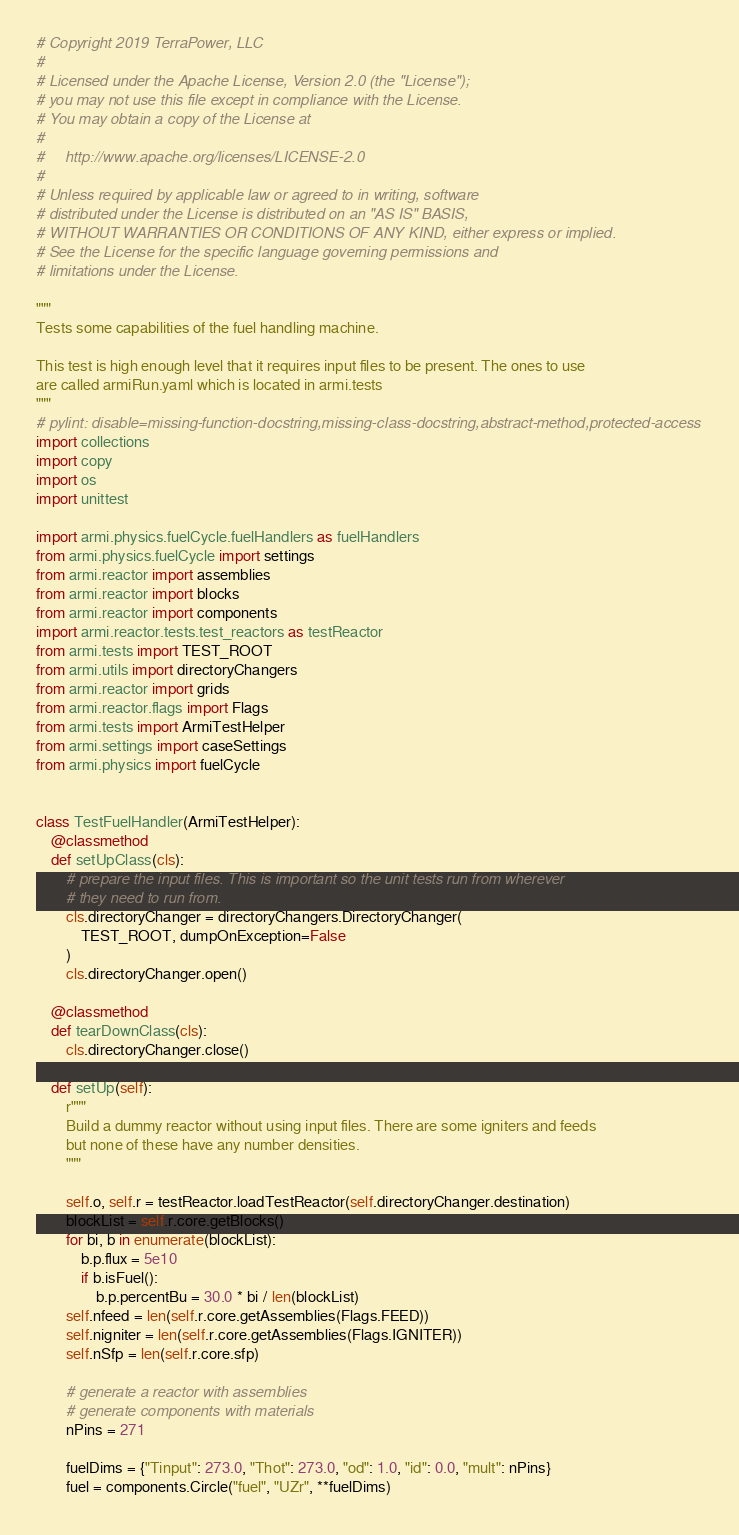Convert code to text. <code><loc_0><loc_0><loc_500><loc_500><_Python_># Copyright 2019 TerraPower, LLC
#
# Licensed under the Apache License, Version 2.0 (the "License");
# you may not use this file except in compliance with the License.
# You may obtain a copy of the License at
#
#     http://www.apache.org/licenses/LICENSE-2.0
#
# Unless required by applicable law or agreed to in writing, software
# distributed under the License is distributed on an "AS IS" BASIS,
# WITHOUT WARRANTIES OR CONDITIONS OF ANY KIND, either express or implied.
# See the License for the specific language governing permissions and
# limitations under the License.

"""
Tests some capabilities of the fuel handling machine.

This test is high enough level that it requires input files to be present. The ones to use
are called armiRun.yaml which is located in armi.tests
"""
# pylint: disable=missing-function-docstring,missing-class-docstring,abstract-method,protected-access
import collections
import copy
import os
import unittest

import armi.physics.fuelCycle.fuelHandlers as fuelHandlers
from armi.physics.fuelCycle import settings
from armi.reactor import assemblies
from armi.reactor import blocks
from armi.reactor import components
import armi.reactor.tests.test_reactors as testReactor
from armi.tests import TEST_ROOT
from armi.utils import directoryChangers
from armi.reactor import grids
from armi.reactor.flags import Flags
from armi.tests import ArmiTestHelper
from armi.settings import caseSettings
from armi.physics import fuelCycle


class TestFuelHandler(ArmiTestHelper):
    @classmethod
    def setUpClass(cls):
        # prepare the input files. This is important so the unit tests run from wherever
        # they need to run from.
        cls.directoryChanger = directoryChangers.DirectoryChanger(
            TEST_ROOT, dumpOnException=False
        )
        cls.directoryChanger.open()

    @classmethod
    def tearDownClass(cls):
        cls.directoryChanger.close()

    def setUp(self):
        r"""
        Build a dummy reactor without using input files. There are some igniters and feeds
        but none of these have any number densities.
        """

        self.o, self.r = testReactor.loadTestReactor(self.directoryChanger.destination)
        blockList = self.r.core.getBlocks()
        for bi, b in enumerate(blockList):
            b.p.flux = 5e10
            if b.isFuel():
                b.p.percentBu = 30.0 * bi / len(blockList)
        self.nfeed = len(self.r.core.getAssemblies(Flags.FEED))
        self.nigniter = len(self.r.core.getAssemblies(Flags.IGNITER))
        self.nSfp = len(self.r.core.sfp)

        # generate a reactor with assemblies
        # generate components with materials
        nPins = 271

        fuelDims = {"Tinput": 273.0, "Thot": 273.0, "od": 1.0, "id": 0.0, "mult": nPins}
        fuel = components.Circle("fuel", "UZr", **fuelDims)
</code> 